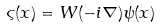<formula> <loc_0><loc_0><loc_500><loc_500>\varsigma ( x ) = W ( - i \nabla ) \psi ( x )</formula> 